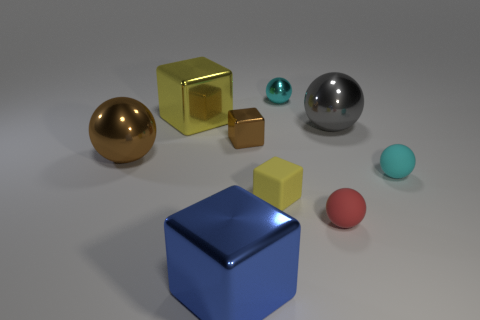Does the blue thing have the same shape as the red matte object?
Your answer should be compact. No. There is a tiny red object that is the same shape as the large brown object; what material is it?
Give a very brief answer. Rubber. What number of large shiny objects are the same color as the small metal cube?
Your answer should be compact. 1. What size is the brown thing that is made of the same material as the big brown sphere?
Your answer should be compact. Small. What number of brown objects are either metallic cubes or tiny cubes?
Keep it short and to the point. 1. What number of small shiny things are in front of the tiny cyan sphere left of the gray thing?
Ensure brevity in your answer.  1. Are there more yellow cubes behind the tiny brown cube than big objects that are behind the gray ball?
Provide a short and direct response. No. What is the material of the blue block?
Give a very brief answer. Metal. Is there a purple rubber ball of the same size as the red object?
Your answer should be compact. No. There is a gray thing that is the same size as the blue metallic cube; what material is it?
Provide a short and direct response. Metal. 